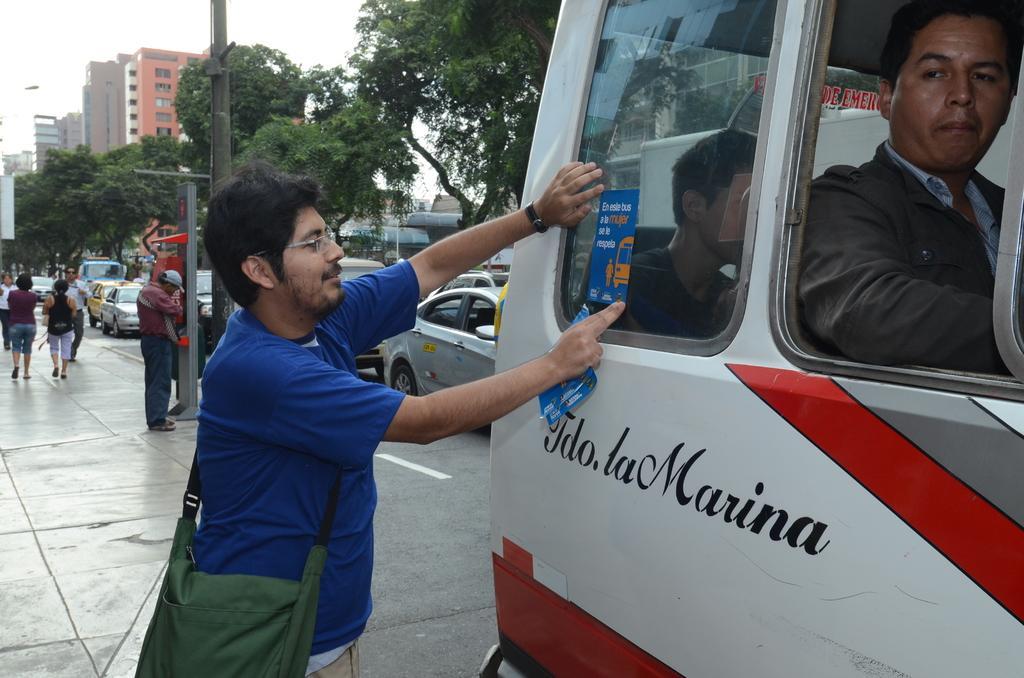In one or two sentences, can you explain what this image depicts? This image is taken outdoors. At the bottom of the image there is a sidewalk. On the right side of the image a van is parked on the road. In the middle of the image a man is standing on the floor and he is sticking a label on the van. Many cars are moving on the road. On the left side of the image a few people are walking on the sidewalk and a few are standing and there is a pole. In the background there are a few trees and buildings. 